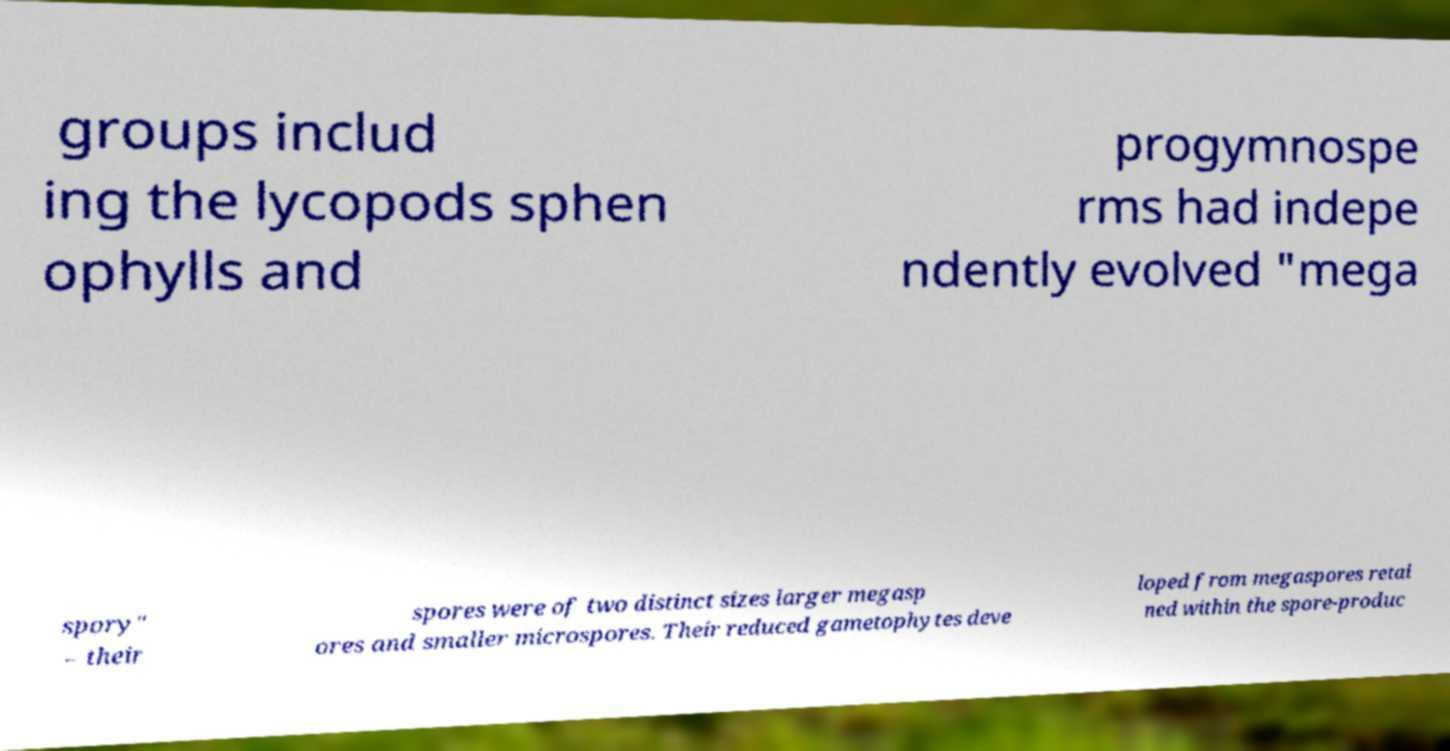Please identify and transcribe the text found in this image. groups includ ing the lycopods sphen ophylls and progymnospe rms had indepe ndently evolved "mega spory" – their spores were of two distinct sizes larger megasp ores and smaller microspores. Their reduced gametophytes deve loped from megaspores retai ned within the spore-produc 